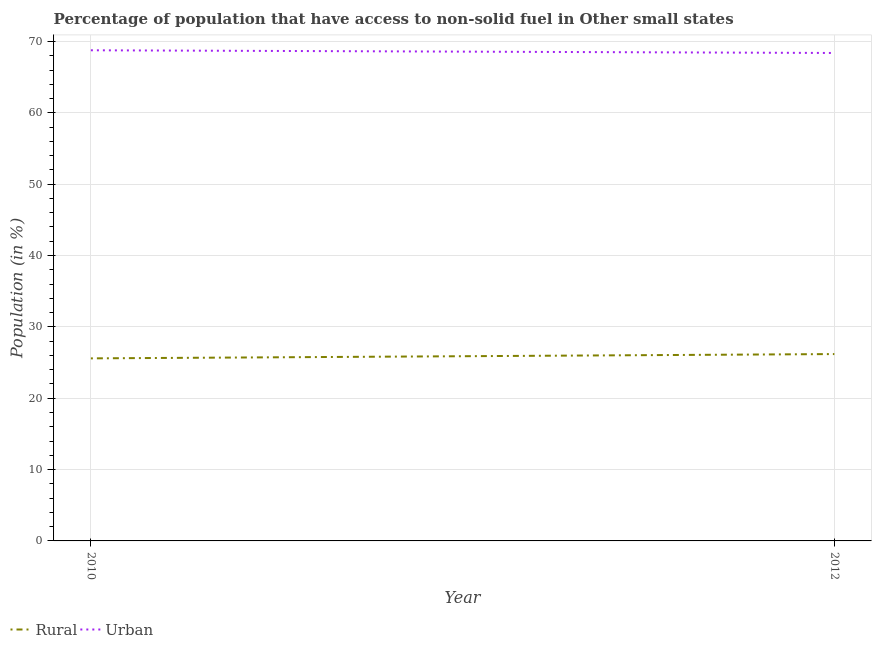What is the rural population in 2012?
Your answer should be very brief. 26.19. Across all years, what is the maximum urban population?
Your answer should be compact. 68.77. Across all years, what is the minimum rural population?
Keep it short and to the point. 25.58. What is the total rural population in the graph?
Offer a very short reply. 51.77. What is the difference between the urban population in 2010 and that in 2012?
Your answer should be very brief. 0.38. What is the difference between the urban population in 2012 and the rural population in 2010?
Provide a short and direct response. 42.8. What is the average urban population per year?
Offer a terse response. 68.58. In the year 2010, what is the difference between the urban population and rural population?
Your answer should be compact. 43.18. What is the ratio of the rural population in 2010 to that in 2012?
Offer a very short reply. 0.98. Does the graph contain any zero values?
Provide a succinct answer. No. How are the legend labels stacked?
Ensure brevity in your answer.  Horizontal. What is the title of the graph?
Keep it short and to the point. Percentage of population that have access to non-solid fuel in Other small states. Does "Highest 20% of population" appear as one of the legend labels in the graph?
Make the answer very short. No. What is the Population (in %) of Rural in 2010?
Offer a terse response. 25.58. What is the Population (in %) of Urban in 2010?
Your answer should be very brief. 68.77. What is the Population (in %) in Rural in 2012?
Provide a succinct answer. 26.19. What is the Population (in %) of Urban in 2012?
Make the answer very short. 68.39. Across all years, what is the maximum Population (in %) in Rural?
Offer a very short reply. 26.19. Across all years, what is the maximum Population (in %) of Urban?
Ensure brevity in your answer.  68.77. Across all years, what is the minimum Population (in %) in Rural?
Offer a very short reply. 25.58. Across all years, what is the minimum Population (in %) of Urban?
Ensure brevity in your answer.  68.39. What is the total Population (in %) of Rural in the graph?
Make the answer very short. 51.77. What is the total Population (in %) in Urban in the graph?
Provide a short and direct response. 137.15. What is the difference between the Population (in %) of Rural in 2010 and that in 2012?
Give a very brief answer. -0.6. What is the difference between the Population (in %) in Urban in 2010 and that in 2012?
Make the answer very short. 0.38. What is the difference between the Population (in %) of Rural in 2010 and the Population (in %) of Urban in 2012?
Offer a terse response. -42.8. What is the average Population (in %) in Rural per year?
Your response must be concise. 25.89. What is the average Population (in %) in Urban per year?
Provide a short and direct response. 68.58. In the year 2010, what is the difference between the Population (in %) in Rural and Population (in %) in Urban?
Your response must be concise. -43.18. In the year 2012, what is the difference between the Population (in %) in Rural and Population (in %) in Urban?
Offer a very short reply. -42.2. What is the difference between the highest and the second highest Population (in %) in Rural?
Your answer should be very brief. 0.6. What is the difference between the highest and the second highest Population (in %) in Urban?
Your response must be concise. 0.38. What is the difference between the highest and the lowest Population (in %) in Rural?
Your response must be concise. 0.6. What is the difference between the highest and the lowest Population (in %) in Urban?
Make the answer very short. 0.38. 